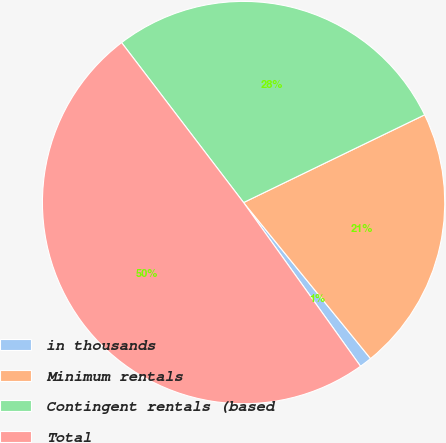Convert chart to OTSL. <chart><loc_0><loc_0><loc_500><loc_500><pie_chart><fcel>in thousands<fcel>Minimum rentals<fcel>Contingent rentals (based<fcel>Total<nl><fcel>1.0%<fcel>21.31%<fcel>28.19%<fcel>49.5%<nl></chart> 